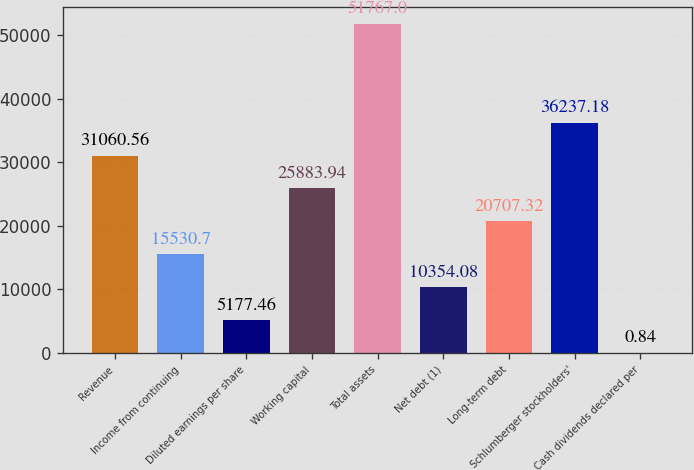Convert chart to OTSL. <chart><loc_0><loc_0><loc_500><loc_500><bar_chart><fcel>Revenue<fcel>Income from continuing<fcel>Diluted earnings per share<fcel>Working capital<fcel>Total assets<fcel>Net debt (1)<fcel>Long-term debt<fcel>Schlumberger stockholders'<fcel>Cash dividends declared per<nl><fcel>31060.6<fcel>15530.7<fcel>5177.46<fcel>25883.9<fcel>51767<fcel>10354.1<fcel>20707.3<fcel>36237.2<fcel>0.84<nl></chart> 